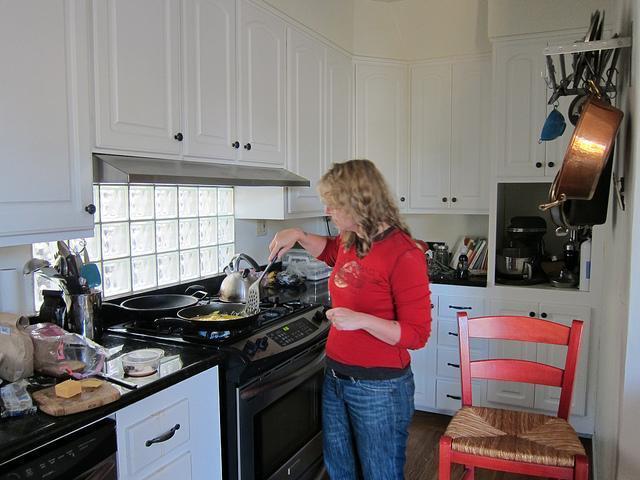How many chairs are in the picture?
Give a very brief answer. 1. 